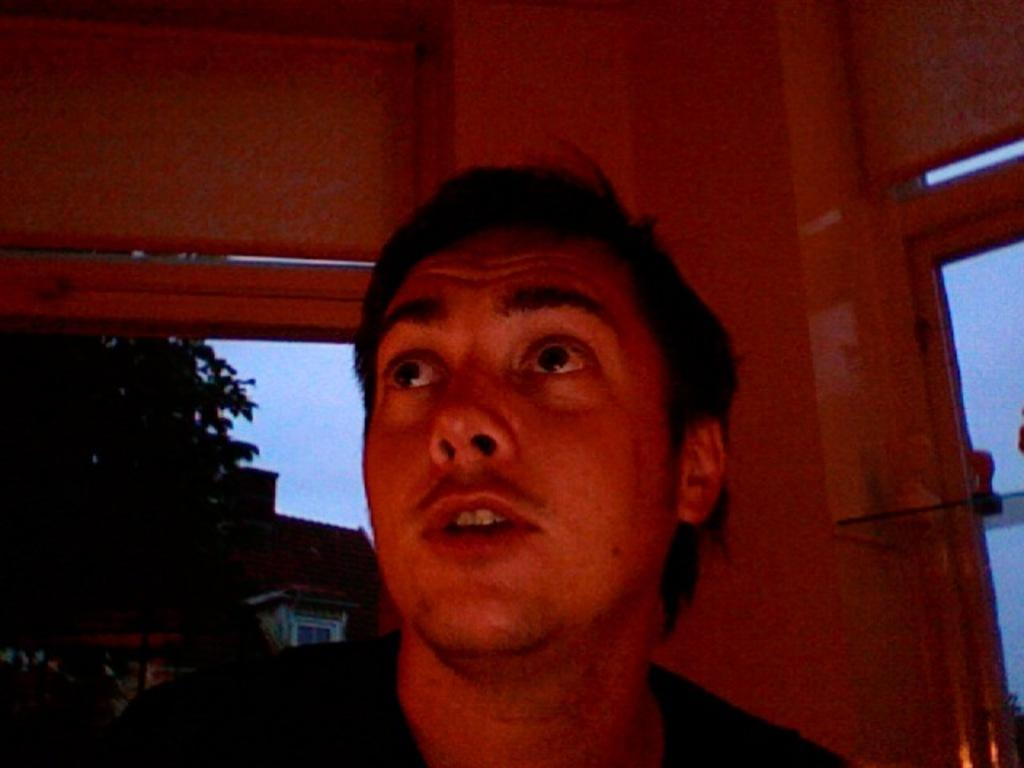Who is present in the image? There is a man in the image. What is the man looking at? The man is looking at the top. What can be seen on the left side of the image? There are trees and buildings on the left side of the image. How many cherries are on the man's head in the image? There are no cherries present in the image, so it is not possible to determine how many cherries might be on the man's head. 